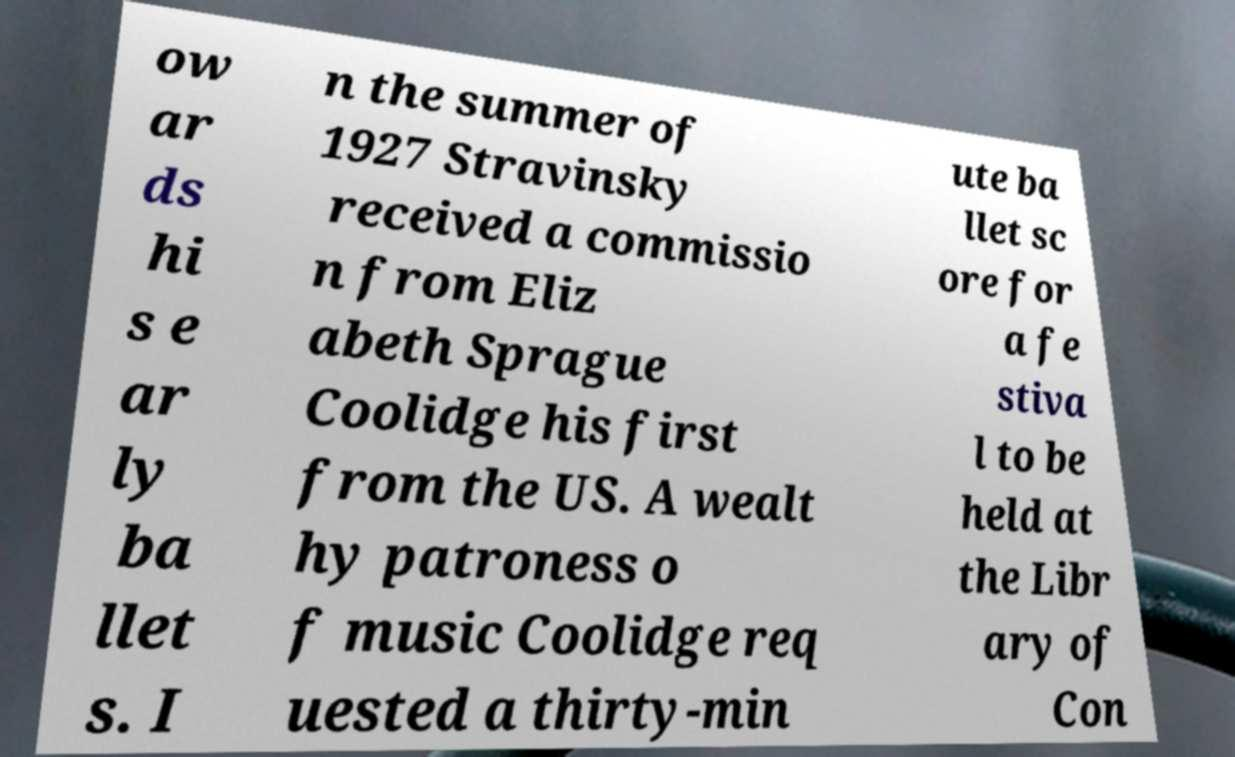Please read and relay the text visible in this image. What does it say? ow ar ds hi s e ar ly ba llet s. I n the summer of 1927 Stravinsky received a commissio n from Eliz abeth Sprague Coolidge his first from the US. A wealt hy patroness o f music Coolidge req uested a thirty-min ute ba llet sc ore for a fe stiva l to be held at the Libr ary of Con 